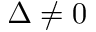<formula> <loc_0><loc_0><loc_500><loc_500>\Delta \neq 0</formula> 